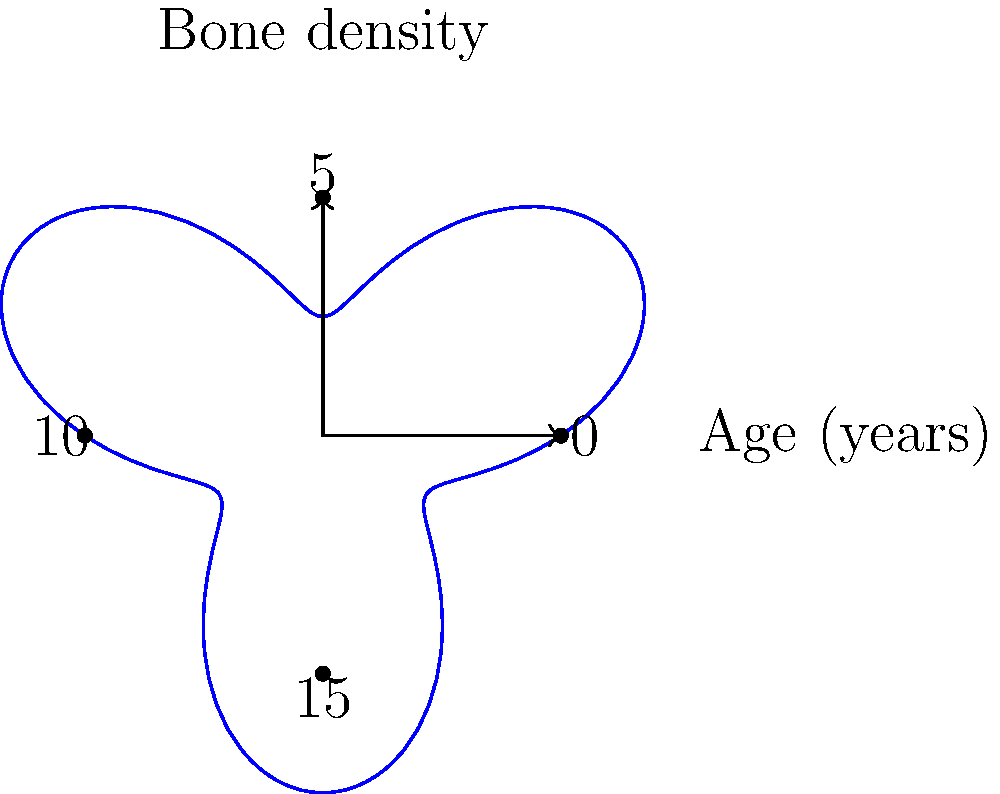As a concerned parent discussing your child's bone health with their teacher, you've been presented with a polar coordinate graph showing your child's bone density growth over time. The graph uses the equation $r = 1 + 0.5\sin(3\theta)$, where $r$ represents bone density and $\theta$ represents age in years (with $2\pi$ radians equal to 20 years). At what age (in years) does your child's bone density reach its first peak after birth? To solve this problem, we need to follow these steps:

1) In polar coordinates, peaks occur when $\frac{dr}{d\theta} = 0$. Let's find this derivative:

   $\frac{dr}{d\theta} = 0.5 \cdot 3 \cos(3\theta) = 1.5\cos(3\theta)$

2) Set this equal to zero and solve:

   $1.5\cos(3\theta) = 0$
   $\cos(3\theta) = 0$

3) The cosine function equals zero when its argument is an odd multiple of $\frac{\pi}{2}$. So:

   $3\theta = \frac{\pi}{2}$
   $\theta = \frac{\pi}{6}$

4) This is the first positive solution, which corresponds to the first peak after birth.

5) Now, we need to convert this to years. We're given that $2\pi$ radians corresponds to 20 years. So:

   $\frac{\pi}{6}$ radians = $\frac{20}{2\pi} \cdot \frac{\pi}{6} = \frac{10}{6} \approx 1.67$ years

Therefore, the child's bone density reaches its first peak approximately 1.67 years after birth.
Answer: 1.67 years 